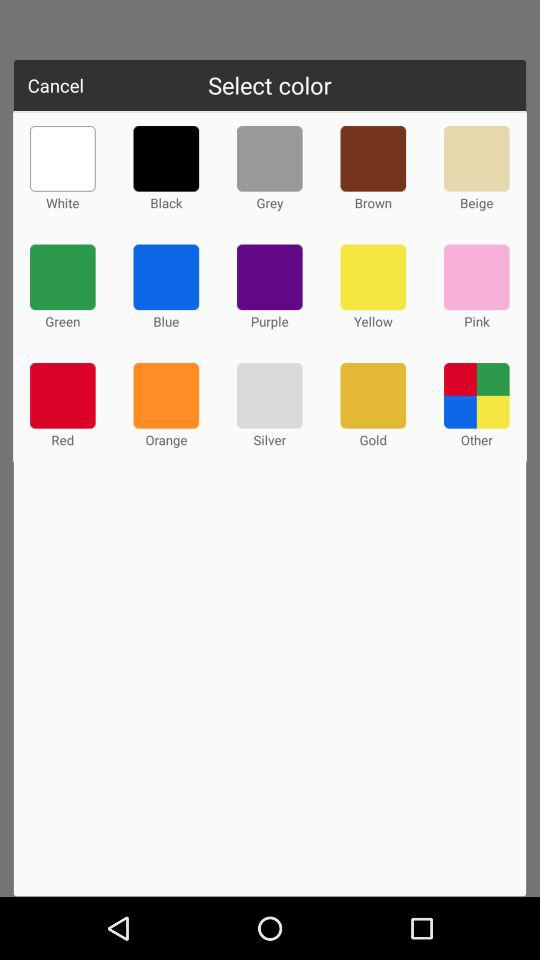What are the names of the colors given to select from? The names of the colors are white, black, grey, brown, beige, green, blue, purple, yellow, pink, red, orange, silver and gold. 